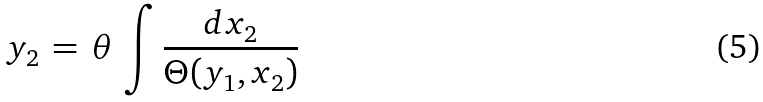<formula> <loc_0><loc_0><loc_500><loc_500>y _ { 2 } \, = \, \theta \, \int \frac { d x _ { 2 } } { \Theta ( y _ { 1 } , x _ { 2 } ) }</formula> 